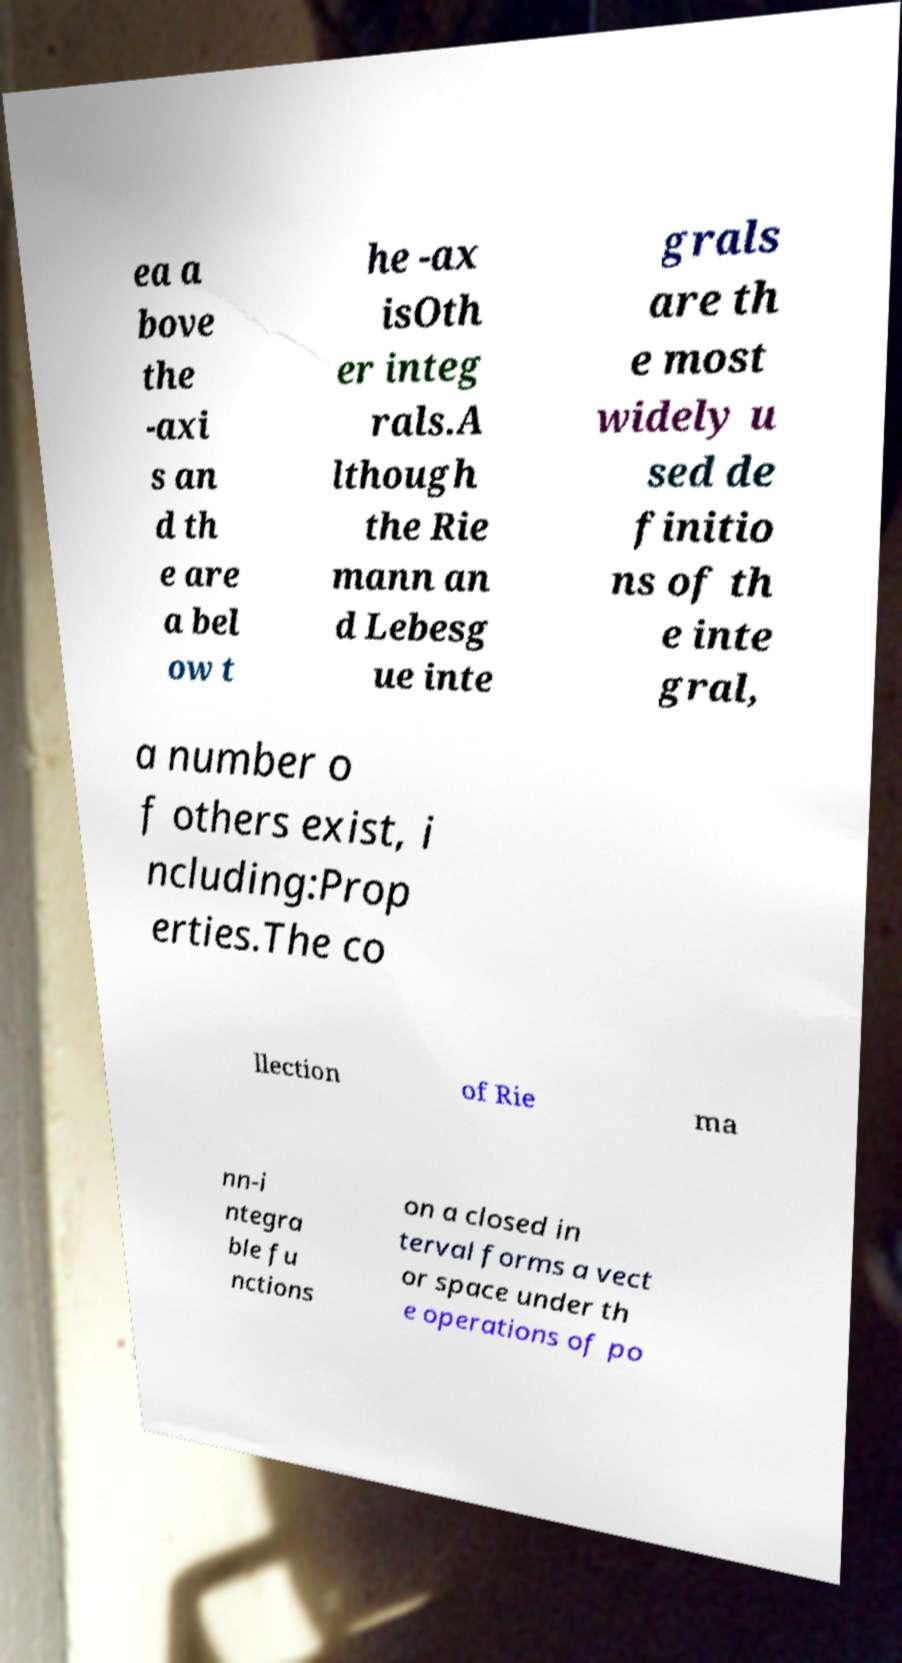Can you accurately transcribe the text from the provided image for me? ea a bove the -axi s an d th e are a bel ow t he -ax isOth er integ rals.A lthough the Rie mann an d Lebesg ue inte grals are th e most widely u sed de finitio ns of th e inte gral, a number o f others exist, i ncluding:Prop erties.The co llection of Rie ma nn-i ntegra ble fu nctions on a closed in terval forms a vect or space under th e operations of po 